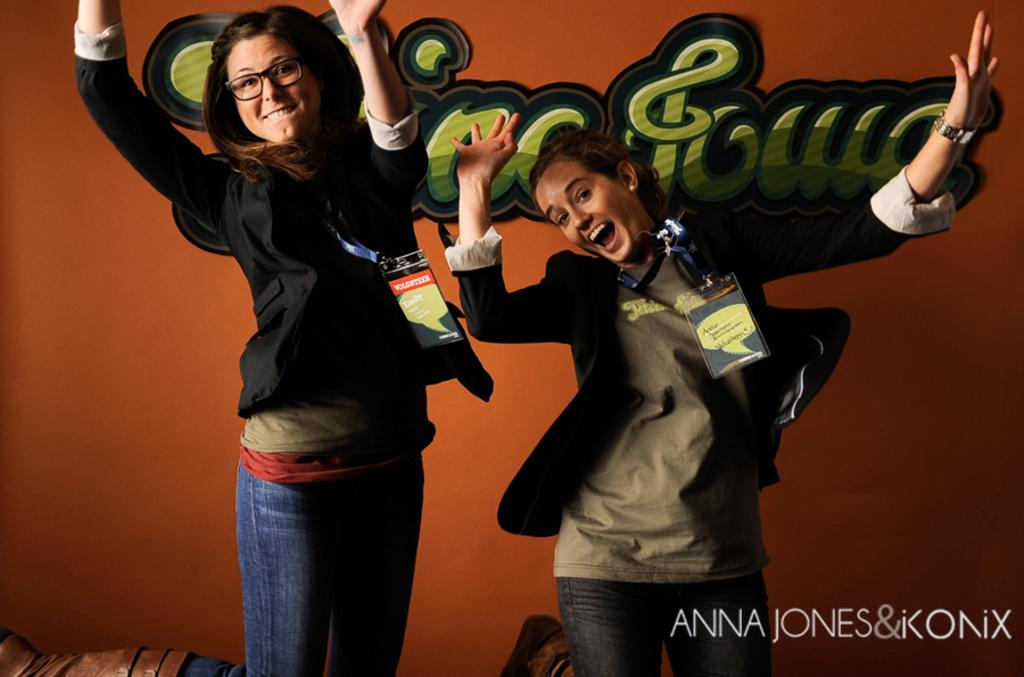Who are the main subjects in the image? There are women in the center of the image. What can be seen in the background of the image? There is a wall in the background of the image. How many dogs are playing with the vessel in the image? There are no dogs or vessels present in the image. What type of squirrel can be seen climbing the wall in the image? There is no squirrel present in the image; only the women and the wall are visible. 